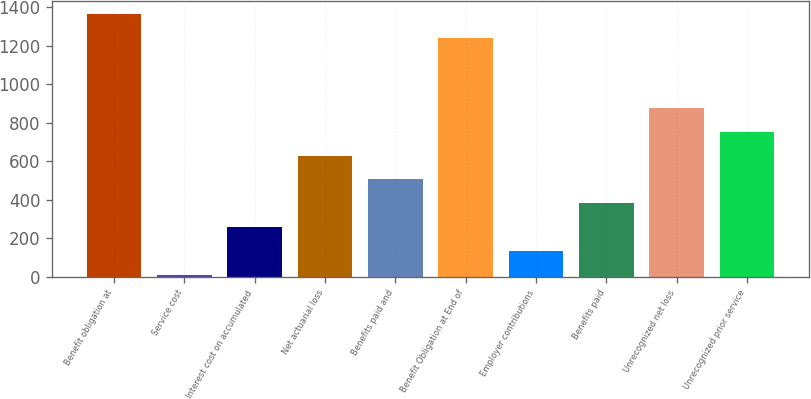Convert chart to OTSL. <chart><loc_0><loc_0><loc_500><loc_500><bar_chart><fcel>Benefit obligation at<fcel>Service cost<fcel>Interest cost on accumulated<fcel>Net actuarial loss<fcel>Benefits paid and<fcel>Benefit Obligation at End of<fcel>Employer contributions<fcel>Benefits paid<fcel>Unrecognized net loss<fcel>Unrecognized prior service<nl><fcel>1361.8<fcel>10<fcel>257.6<fcel>629<fcel>505.2<fcel>1238<fcel>133.8<fcel>381.4<fcel>876.6<fcel>752.8<nl></chart> 